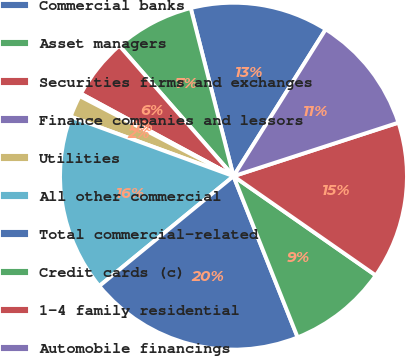Convert chart. <chart><loc_0><loc_0><loc_500><loc_500><pie_chart><fcel>Commercial banks<fcel>Asset managers<fcel>Securities firms and exchanges<fcel>Finance companies and lessors<fcel>Utilities<fcel>All other commercial<fcel>Total commercial-related<fcel>Credit cards (c)<fcel>1-4 family residential<fcel>Automobile financings<nl><fcel>12.89%<fcel>7.47%<fcel>5.67%<fcel>0.25%<fcel>2.06%<fcel>16.5%<fcel>20.11%<fcel>9.28%<fcel>14.69%<fcel>11.08%<nl></chart> 